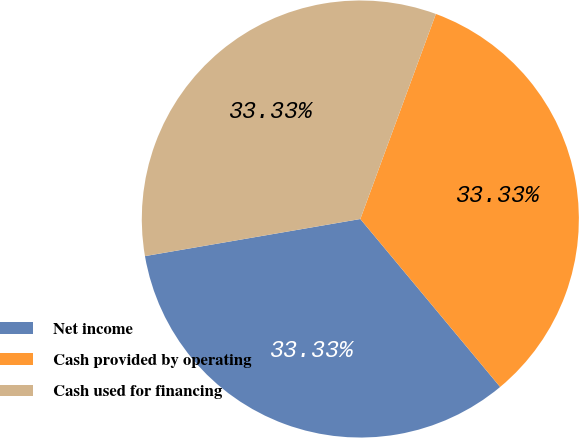Convert chart to OTSL. <chart><loc_0><loc_0><loc_500><loc_500><pie_chart><fcel>Net income<fcel>Cash provided by operating<fcel>Cash used for financing<nl><fcel>33.33%<fcel>33.33%<fcel>33.33%<nl></chart> 